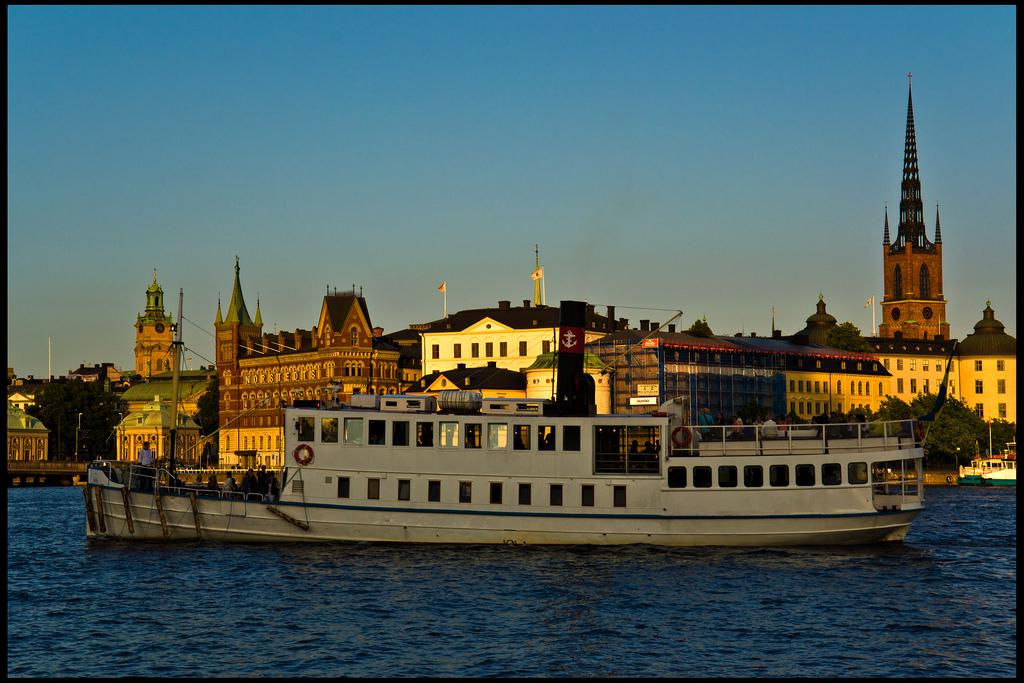Question: how does the water look?
Choices:
A. Clear.
B. Choppy and dark.
C. Blue.
D. Black.
Answer with the letter. Answer: B Question: how does the water look?
Choices:
A. Violent.
B. Blue.
C. Calm.
D. Muddy.
Answer with the letter. Answer: C Question: what is painted on the boat's smoke stack?
Choices:
A. A broad yellow stripe and a black anchor.
B. A broad black stripe and a yellow anchor.
C. A thin white stripe and a yellow anchor.
D. A broad white stripe and a white anchor.
Answer with the letter. Answer: D Question: how does the sky look?
Choices:
A. Sunny.
B. Cloudless.
C. Blue.
D. Foggy.
Answer with the letter. Answer: B Question: why is it dim?
Choices:
A. No lights are on.
B. The sun is setting.
C. It is taken inside.
D. It is taken under an umbrella.
Answer with the letter. Answer: B Question: what is behind the boat?
Choices:
A. Many different buildings.
B. Other boats.
C. A giant wave.
D. A flock of birds.
Answer with the letter. Answer: A Question: where is a building with a tall, thin steeple?
Choices:
A. It is on the right.
B. Down the street.
C. It's over there.
D. Up there.
Answer with the letter. Answer: A Question: how many boats are there?
Choices:
A. One.
B. Two.
C. Three.
D. Four.
Answer with the letter. Answer: A Question: what time of day is it?
Choices:
A. Evening.
B. Dawn.
C. Dusk.
D. Afternoon.
Answer with the letter. Answer: A Question: when is the photo taken?
Choices:
A. In the morning.
B. In the afternoon.
C. At dusk.
D. During the evening.
Answer with the letter. Answer: D Question: where can people be seen within the boat?
Choices:
A. In the galley.
B. On the deck.
C. On the sail.
D. On the rudder.
Answer with the letter. Answer: B Question: when is the boat sitting in the middle of the lake?
Choices:
A. First thing in the morning.
B. Just after lunchtime.
C. Late at night.
D. Early evening.
Answer with the letter. Answer: D Question: where are there flags flying?
Choices:
A. On a flagpole in the front.
B. On the side of the building to the right.
C. Atop one of the buildings in the distance.
D. In the back near the ground.
Answer with the letter. Answer: C Question: what type of windows does the boat have?
Choices:
A. Round windows.
B. Square windows.
C. All types of windows.
D. Many different windows.
Answer with the letter. Answer: D Question: where are the people on the boat?
Choices:
A. Inside the boat.
B. On the deck.
C. In the water.
D. Some are seated outside and others are inside.
Answer with the letter. Answer: D Question: what is in the foreground?
Choices:
A. Trees.
B. Cabin.
C. A white boat.
D. A blue boat.
Answer with the letter. Answer: C 